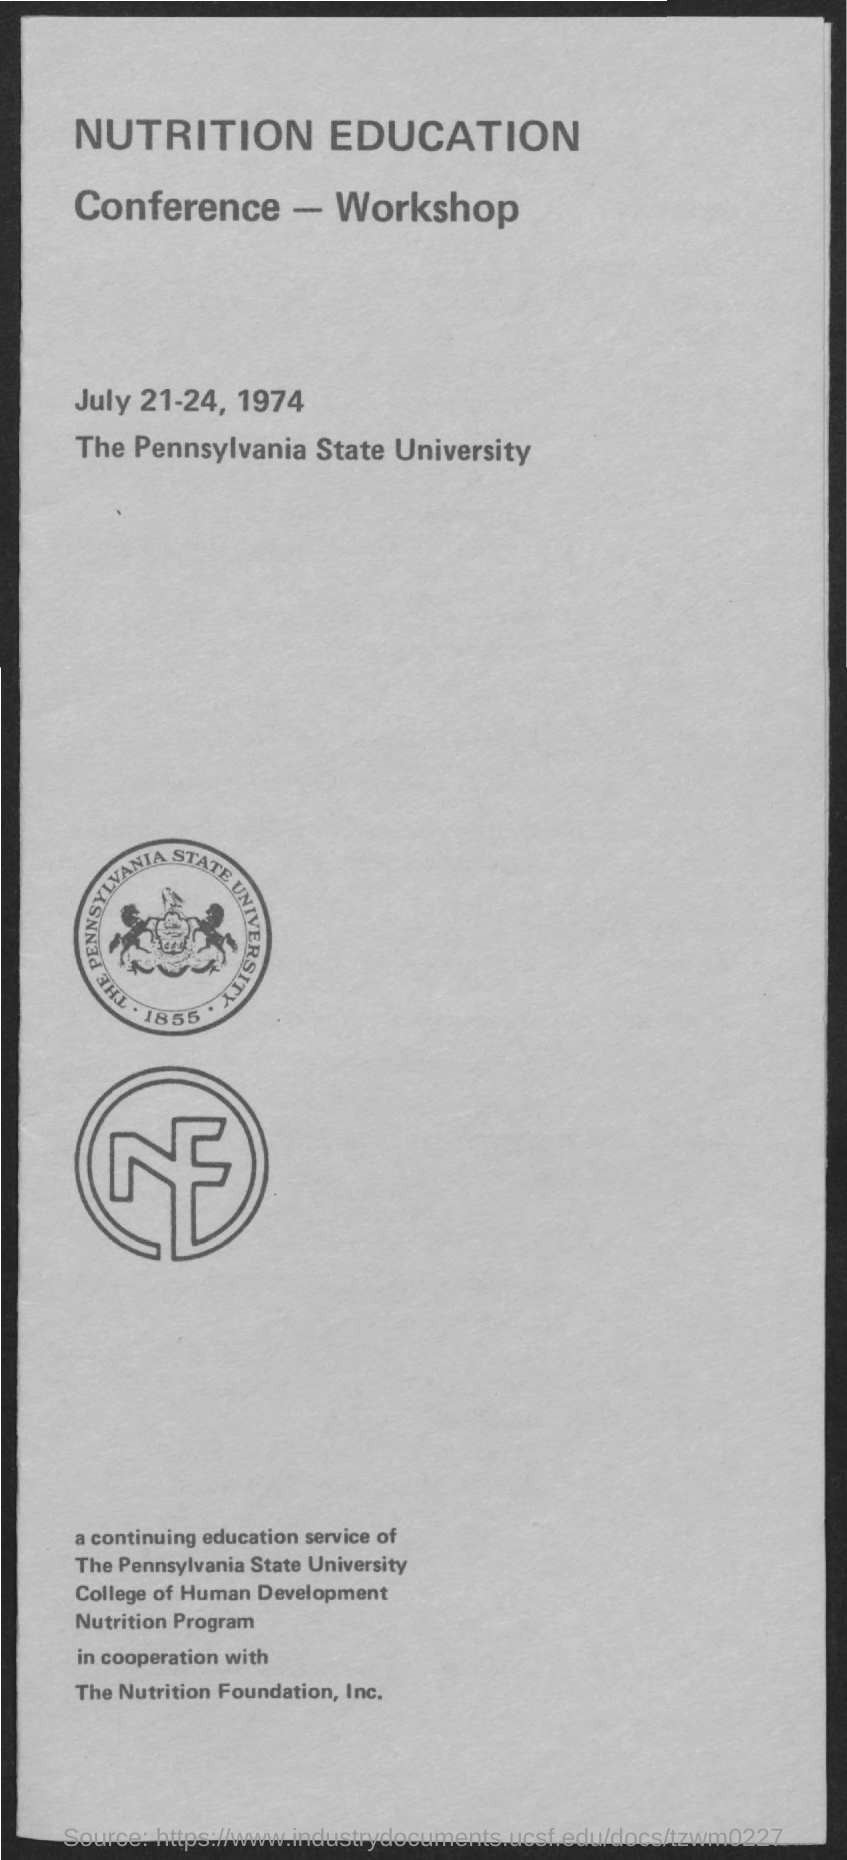Highlight a few significant elements in this photo. The Pennsylvania State University is the location where the Conference-Workshop is held. The Conference-Workshop was held on July 21-24, 1974. 